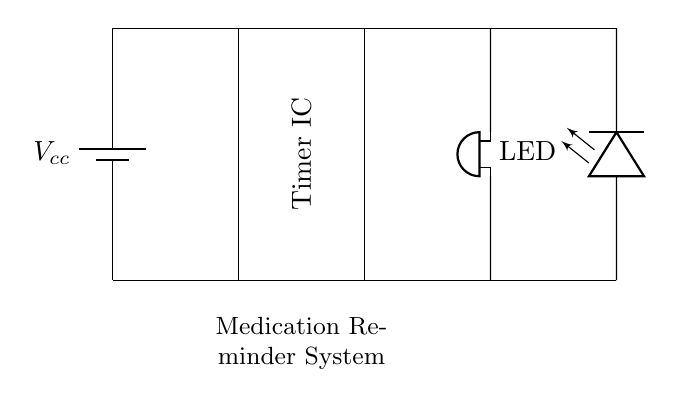What components are used in this circuit? The circuit includes a battery, a timer IC, a buzzer, and an LED, which are all clearly labeled in the diagram.
Answer: battery, timer IC, buzzer, LED What is the function of the timer IC in this circuit? The timer IC acts as a control unit that determines when to activate the buzzer and LED, signaling medication reminders at predetermined intervals.
Answer: control unit How many connections are in series in this circuit? The components (battery, timer IC, buzzer, and LED) are arranged in a single series loop; therefore, there are three main connections plus the power supply leads.
Answer: three What does the LED indicate in this medication reminder system? The LED typically indicates that the reminder system is activated, signaling the user visually alongside the buzzer sound.
Answer: visual indication What happens when power is supplied to this circuit? When power is supplied, the timer IC starts, it periodically activates the buzzer and LED to remind the user, demonstrating the operational cycle of the system.
Answer: activates reminders How does the buzzer function in response to the timer IC? The buzzer produces sound when the timer IC signals it to turn on, indicating that it is time for medication; this signifies the auditory notification mechanism.
Answer: sound production 